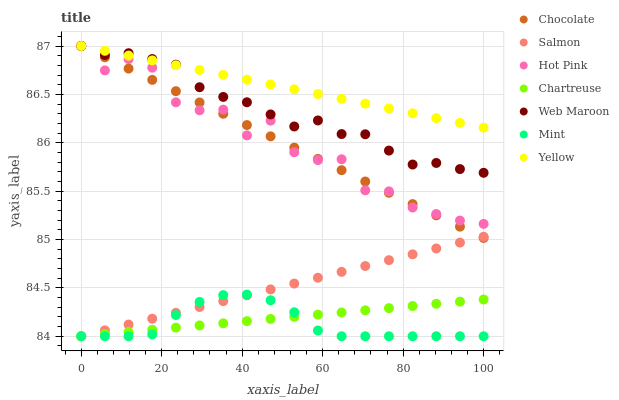Does Mint have the minimum area under the curve?
Answer yes or no. Yes. Does Yellow have the maximum area under the curve?
Answer yes or no. Yes. Does Hot Pink have the minimum area under the curve?
Answer yes or no. No. Does Hot Pink have the maximum area under the curve?
Answer yes or no. No. Is Salmon the smoothest?
Answer yes or no. Yes. Is Hot Pink the roughest?
Answer yes or no. Yes. Is Web Maroon the smoothest?
Answer yes or no. No. Is Web Maroon the roughest?
Answer yes or no. No. Does Salmon have the lowest value?
Answer yes or no. Yes. Does Hot Pink have the lowest value?
Answer yes or no. No. Does Chocolate have the highest value?
Answer yes or no. Yes. Does Chartreuse have the highest value?
Answer yes or no. No. Is Chartreuse less than Hot Pink?
Answer yes or no. Yes. Is Web Maroon greater than Mint?
Answer yes or no. Yes. Does Salmon intersect Chocolate?
Answer yes or no. Yes. Is Salmon less than Chocolate?
Answer yes or no. No. Is Salmon greater than Chocolate?
Answer yes or no. No. Does Chartreuse intersect Hot Pink?
Answer yes or no. No. 